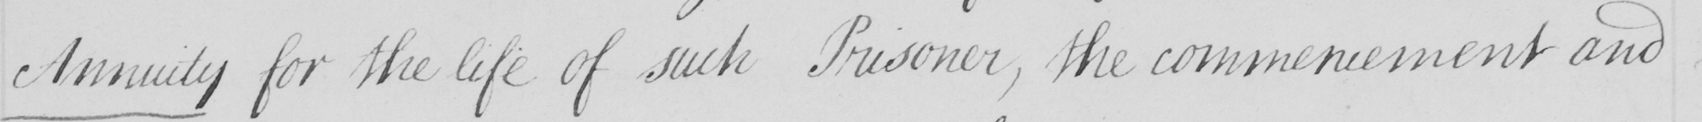Please provide the text content of this handwritten line. Annuity  for the life of such Prisoner , the commencement and 